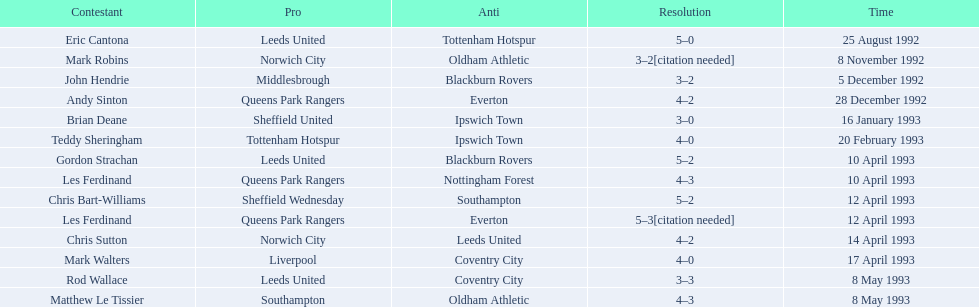Who are all the players? Eric Cantona, Mark Robins, John Hendrie, Andy Sinton, Brian Deane, Teddy Sheringham, Gordon Strachan, Les Ferdinand, Chris Bart-Williams, Les Ferdinand, Chris Sutton, Mark Walters, Rod Wallace, Matthew Le Tissier. What were their results? 5–0, 3–2[citation needed], 3–2, 4–2, 3–0, 4–0, 5–2, 4–3, 5–2, 5–3[citation needed], 4–2, 4–0, 3–3, 4–3. Which player tied with mark robins? John Hendrie. 